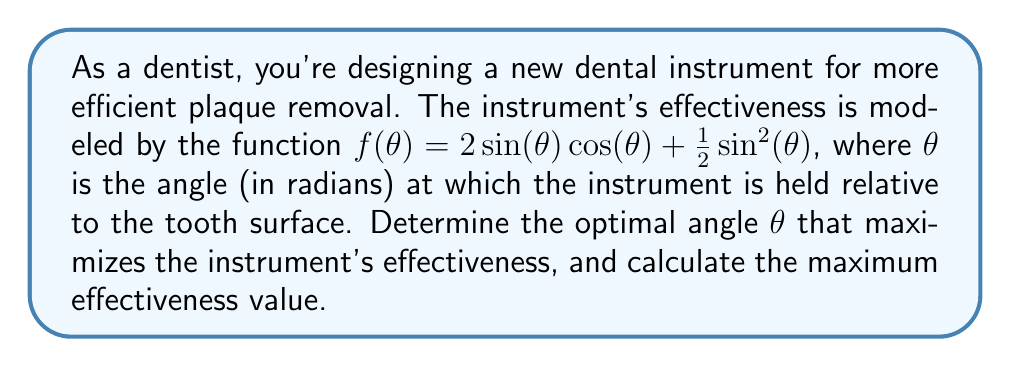Could you help me with this problem? To solve this problem, we'll use calculus to find the maximum of the given function.

1) First, let's simplify the function using the trigonometric identity $\sin(2\theta) = 2\sin(\theta)\cos(\theta)$:

   $f(\theta) = \sin(2\theta) + \frac{1}{2}\sin^2(\theta)$

2) To find the maximum, we need to find where the derivative of $f(\theta)$ equals zero:

   $f'(\theta) = 2\cos(2\theta) + \sin(\theta)\cos(\theta)$

3) Set $f'(\theta) = 0$:

   $2\cos(2\theta) + \sin(\theta)\cos(\theta) = 0$

4) We can simplify this using the double angle formula $\cos(2\theta) = \cos^2(\theta) - \sin^2(\theta)$:

   $2(\cos^2(\theta) - \sin^2(\theta)) + \sin(\theta)\cos(\theta) = 0$

5) Rearrange the terms:

   $2\cos^2(\theta) - 2\sin^2(\theta) + \sin(\theta)\cos(\theta) = 0$

6) Divide by $\cos(\theta)$ (assuming $\cos(\theta) \neq 0$):

   $2\cos(\theta) - 2\sin(\theta)\tan(\theta) + \sin(\theta) = 0$

7) Substitute $u = \tan(\theta)$:

   $\frac{2}{\sqrt{1+u^2}} - 2u\frac{u}{\sqrt{1+u^2}} + \frac{u}{\sqrt{1+u^2}} = 0$

8) Multiply all terms by $\sqrt{1+u^2}$:

   $2 - 2u^2 + u = 0$

9) Rearrange to standard form:

   $2u^2 - u - 2 = 0$

10) Solve this quadratic equation:

    $u = \frac{1 \pm \sqrt{1 + 16}}{4} = \frac{1 \pm \sqrt{17}}{4}$

11) We're only interested in the positive solution (as we're looking for an angle in the first quadrant):

    $u = \frac{1 + \sqrt{17}}{4}$

12) Convert back to $\theta$:

    $\theta = \arctan(\frac{1 + \sqrt{17}}{4}) \approx 0.6435$ radians or about 36.87°

13) To find the maximum effectiveness, plug this value back into the original function:

    $f(\theta) = \sin(2(0.6435)) + \frac{1}{2}\sin^2(0.6435) \approx 1.0353$

Therefore, the optimal angle is approximately 0.6435 radians or 36.87°, and the maximum effectiveness is approximately 1.0353.
Answer: Optimal angle: $\theta \approx 0.6435$ radians or 36.87°
Maximum effectiveness: $f(\theta) \approx 1.0353$ 